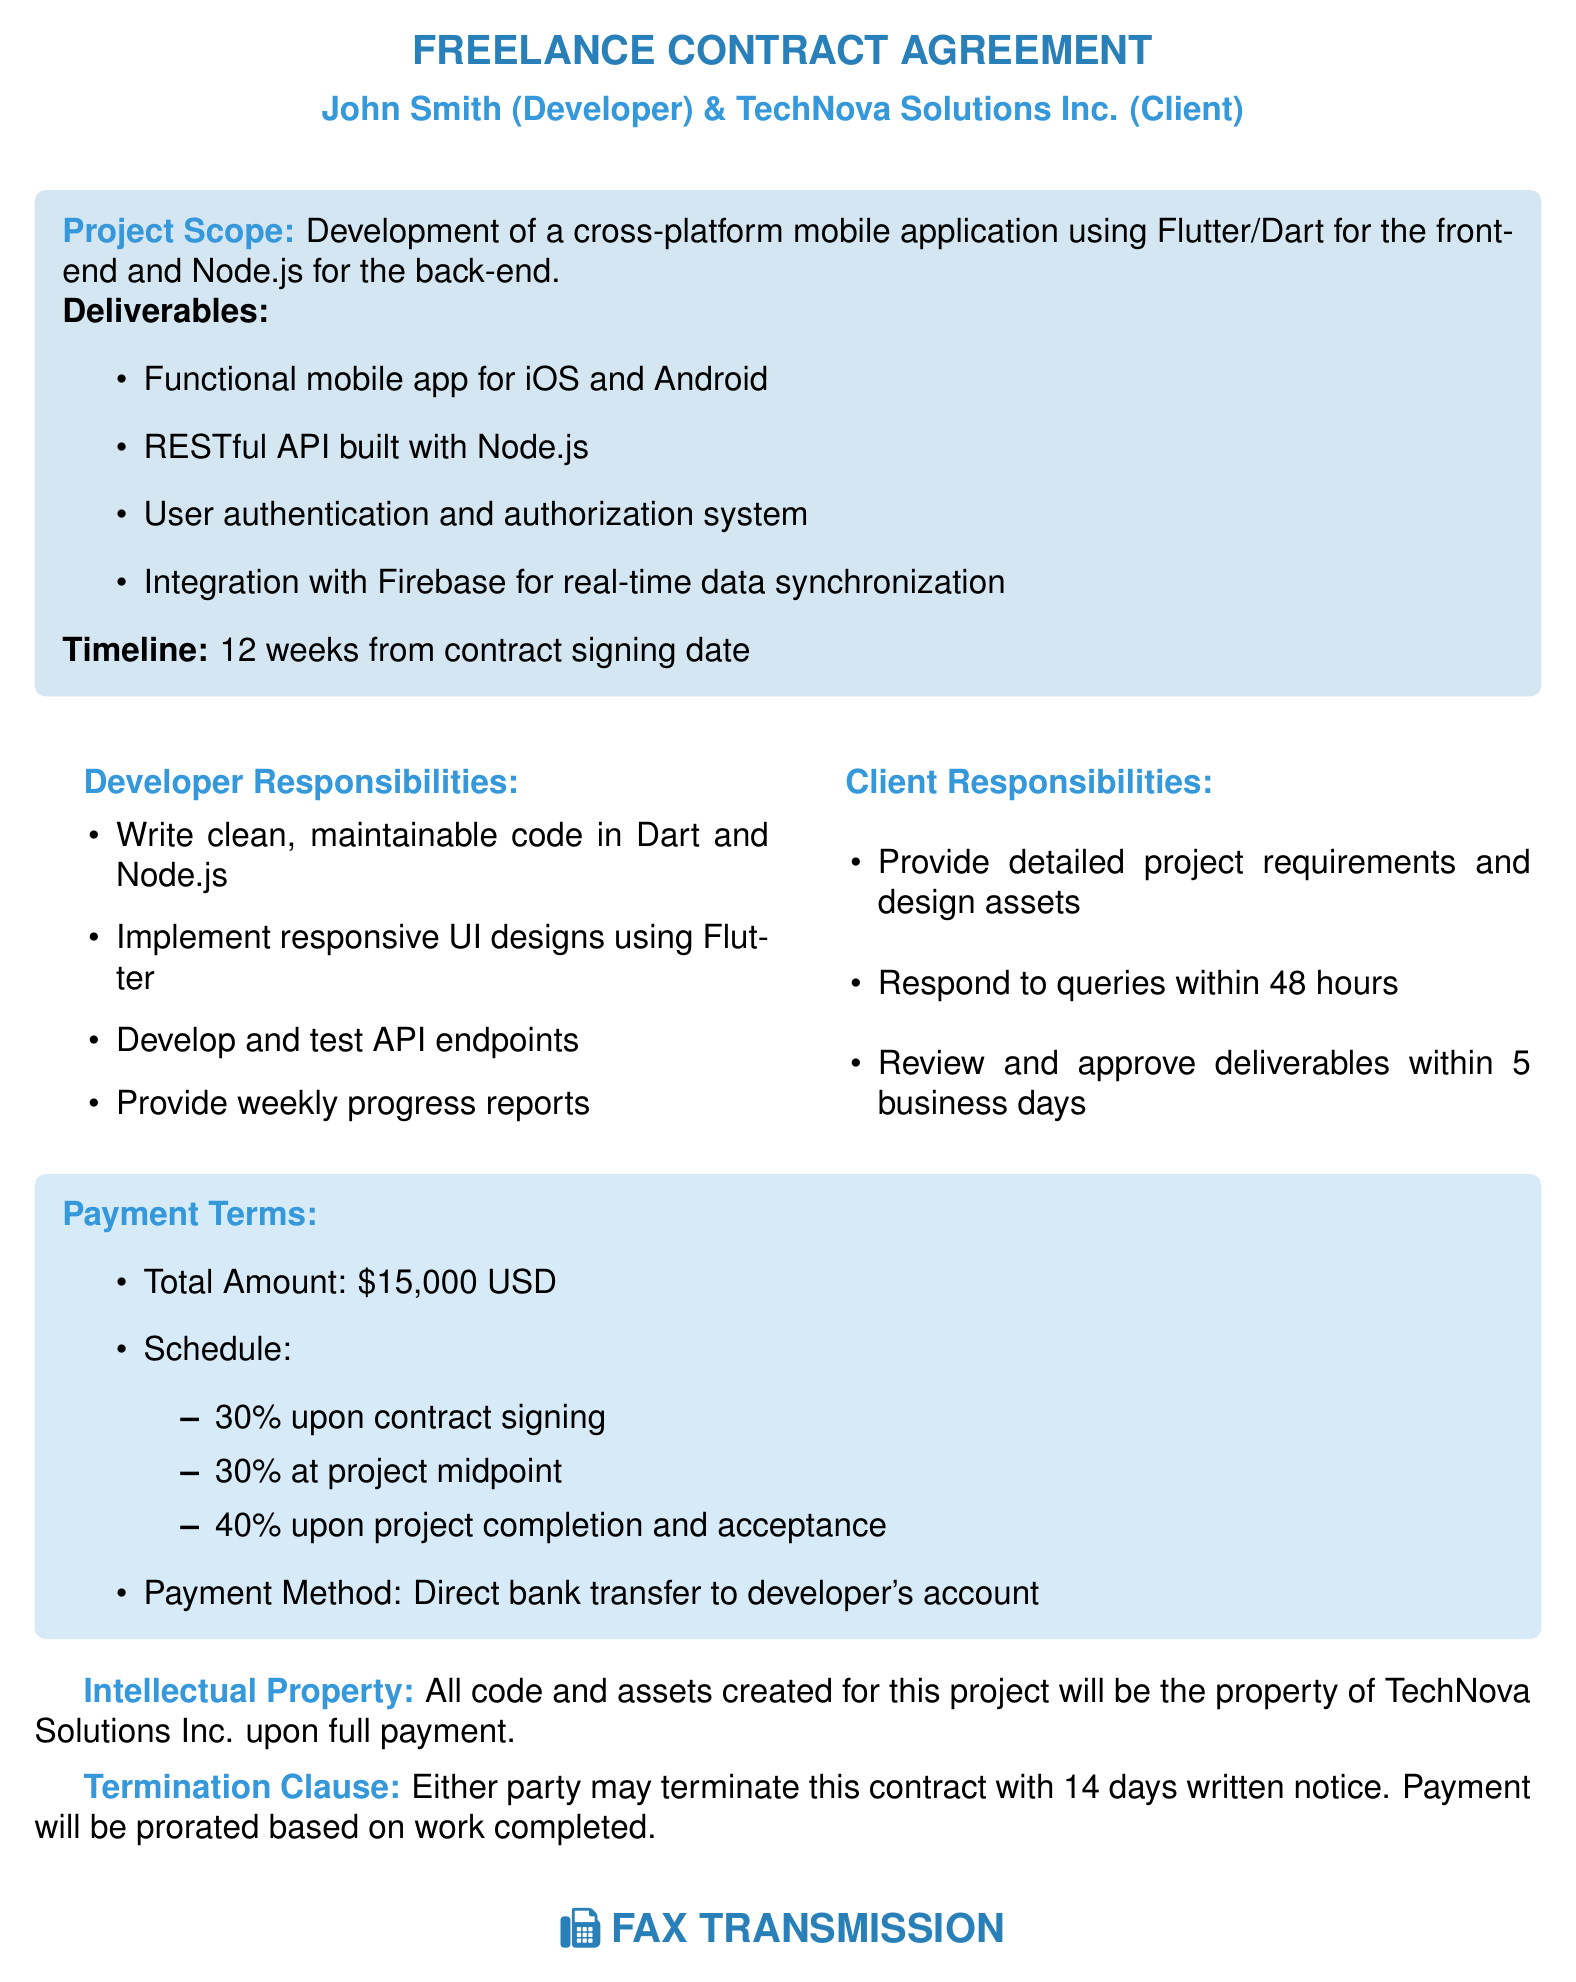what is the name of the developer? The name of the developer mentioned in the document is John Smith.
Answer: John Smith what is the total payment amount? The total payment amount stated in the document is \$15,000 USD.
Answer: \$15,000 USD what is the payment schedule upon contract signing? The payment schedule upon contract signing is 30%.
Answer: 30% how long is the project timeline? The project timeline specified in the document is 12 weeks from the contract signing date.
Answer: 12 weeks what will happen to the intellectual property after payment? The intellectual property will belong to TechNova Solutions Inc. upon full payment.
Answer: TechNova Solutions Inc what is the developer responsible for providing weekly? The developer is responsible for providing weekly progress reports.
Answer: progress reports how much percentage is paid at the project midpoint? At the project midpoint, 30% of the total amount is paid.
Answer: 30% what is the notice period required for contract termination? The notice period required for contract termination is 14 days.
Answer: 14 days which platforms will the mobile app be developed for? The mobile app will be developed for iOS and Android platforms.
Answer: iOS and Android 